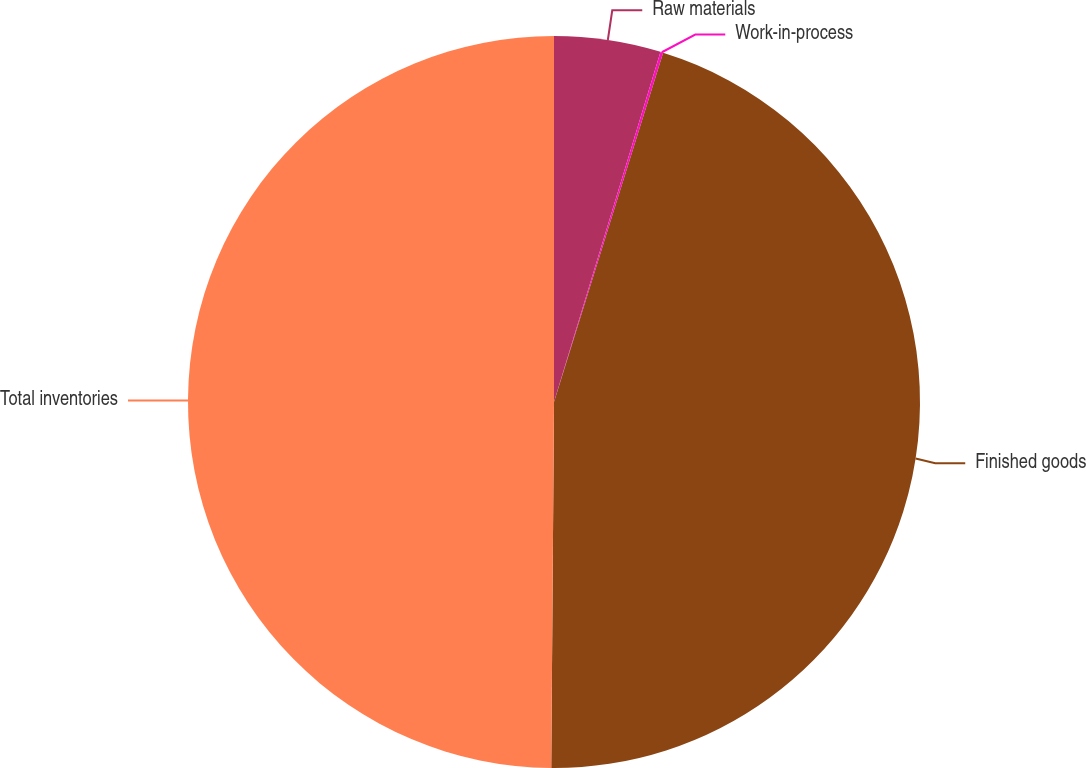Convert chart. <chart><loc_0><loc_0><loc_500><loc_500><pie_chart><fcel>Raw materials<fcel>Work-in-process<fcel>Finished goods<fcel>Total inventories<nl><fcel>4.7%<fcel>0.12%<fcel>45.3%<fcel>49.88%<nl></chart> 